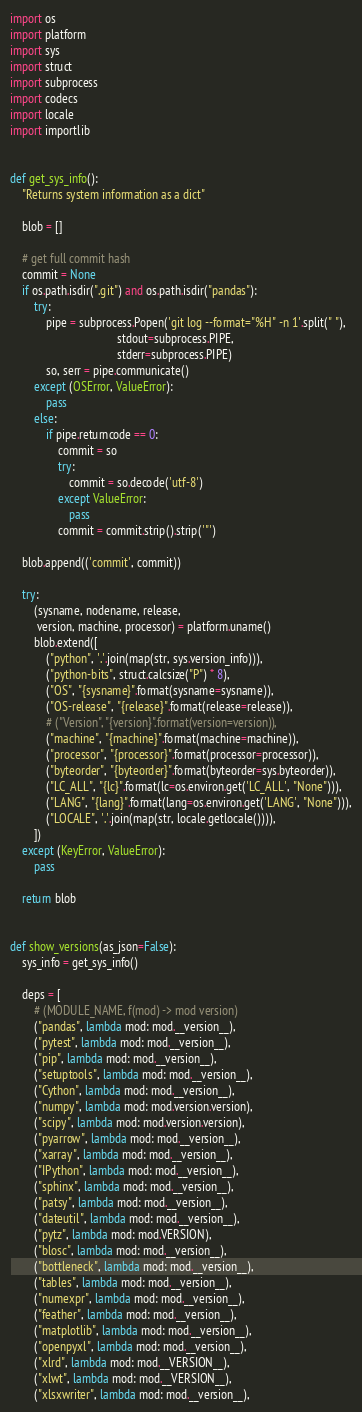Convert code to text. <code><loc_0><loc_0><loc_500><loc_500><_Python_>import os
import platform
import sys
import struct
import subprocess
import codecs
import locale
import importlib


def get_sys_info():
    "Returns system information as a dict"

    blob = []

    # get full commit hash
    commit = None
    if os.path.isdir(".git") and os.path.isdir("pandas"):
        try:
            pipe = subprocess.Popen('git log --format="%H" -n 1'.split(" "),
                                    stdout=subprocess.PIPE,
                                    stderr=subprocess.PIPE)
            so, serr = pipe.communicate()
        except (OSError, ValueError):
            pass
        else:
            if pipe.returncode == 0:
                commit = so
                try:
                    commit = so.decode('utf-8')
                except ValueError:
                    pass
                commit = commit.strip().strip('"')

    blob.append(('commit', commit))

    try:
        (sysname, nodename, release,
         version, machine, processor) = platform.uname()
        blob.extend([
            ("python", '.'.join(map(str, sys.version_info))),
            ("python-bits", struct.calcsize("P") * 8),
            ("OS", "{sysname}".format(sysname=sysname)),
            ("OS-release", "{release}".format(release=release)),
            # ("Version", "{version}".format(version=version)),
            ("machine", "{machine}".format(machine=machine)),
            ("processor", "{processor}".format(processor=processor)),
            ("byteorder", "{byteorder}".format(byteorder=sys.byteorder)),
            ("LC_ALL", "{lc}".format(lc=os.environ.get('LC_ALL', "None"))),
            ("LANG", "{lang}".format(lang=os.environ.get('LANG', "None"))),
            ("LOCALE", '.'.join(map(str, locale.getlocale()))),
        ])
    except (KeyError, ValueError):
        pass

    return blob


def show_versions(as_json=False):
    sys_info = get_sys_info()

    deps = [
        # (MODULE_NAME, f(mod) -> mod version)
        ("pandas", lambda mod: mod.__version__),
        ("pytest", lambda mod: mod.__version__),
        ("pip", lambda mod: mod.__version__),
        ("setuptools", lambda mod: mod.__version__),
        ("Cython", lambda mod: mod.__version__),
        ("numpy", lambda mod: mod.version.version),
        ("scipy", lambda mod: mod.version.version),
        ("pyarrow", lambda mod: mod.__version__),
        ("xarray", lambda mod: mod.__version__),
        ("IPython", lambda mod: mod.__version__),
        ("sphinx", lambda mod: mod.__version__),
        ("patsy", lambda mod: mod.__version__),
        ("dateutil", lambda mod: mod.__version__),
        ("pytz", lambda mod: mod.VERSION),
        ("blosc", lambda mod: mod.__version__),
        ("bottleneck", lambda mod: mod.__version__),
        ("tables", lambda mod: mod.__version__),
        ("numexpr", lambda mod: mod.__version__),
        ("feather", lambda mod: mod.__version__),
        ("matplotlib", lambda mod: mod.__version__),
        ("openpyxl", lambda mod: mod.__version__),
        ("xlrd", lambda mod: mod.__VERSION__),
        ("xlwt", lambda mod: mod.__VERSION__),
        ("xlsxwriter", lambda mod: mod.__version__),</code> 